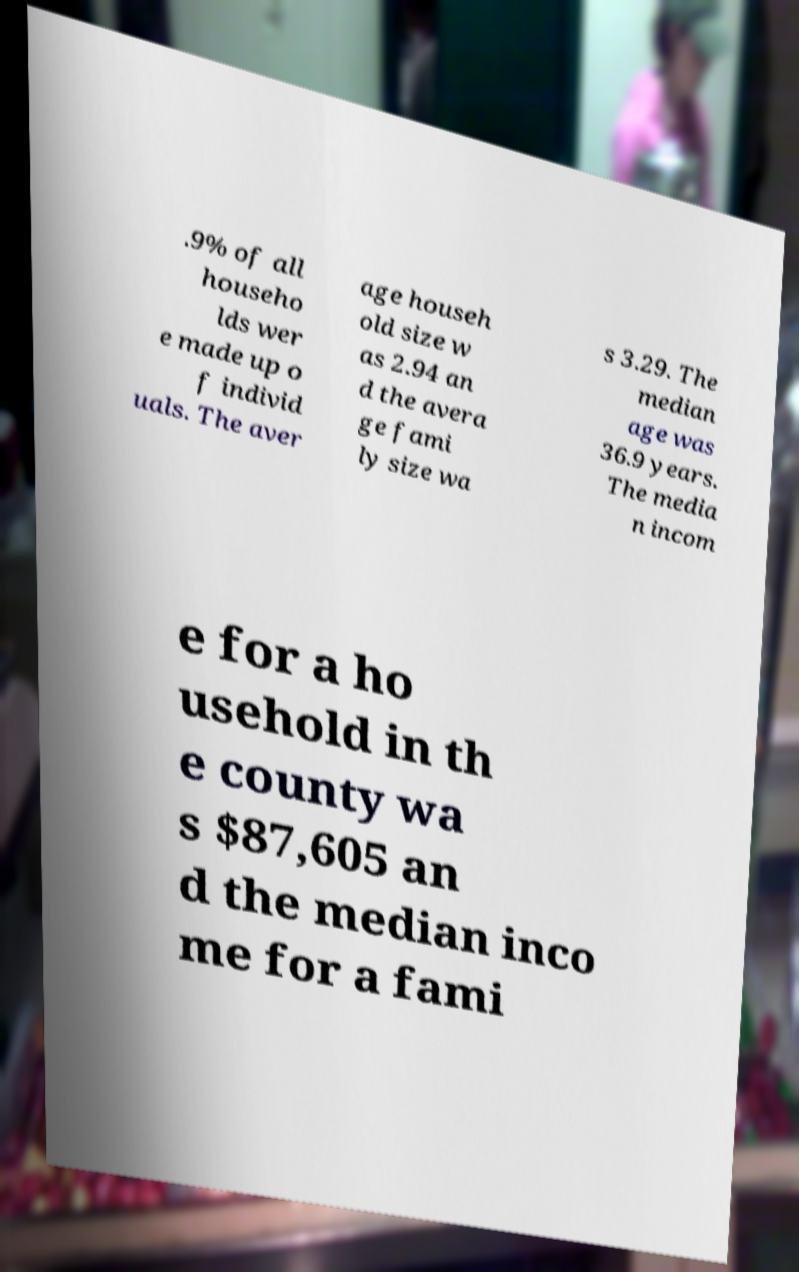Could you extract and type out the text from this image? .9% of all househo lds wer e made up o f individ uals. The aver age househ old size w as 2.94 an d the avera ge fami ly size wa s 3.29. The median age was 36.9 years. The media n incom e for a ho usehold in th e county wa s $87,605 an d the median inco me for a fami 